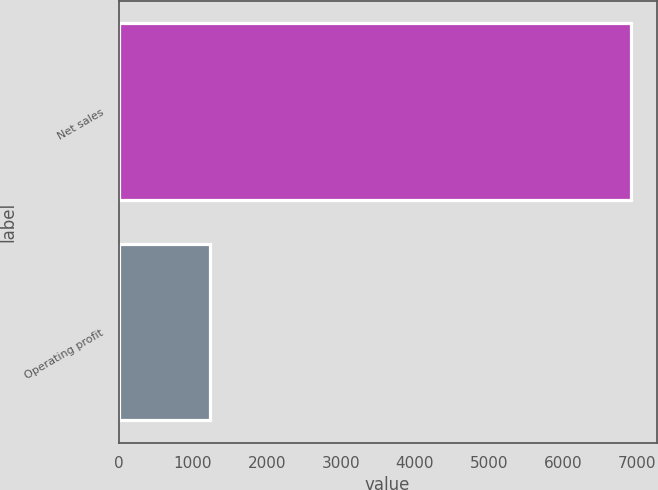Convert chart to OTSL. <chart><loc_0><loc_0><loc_500><loc_500><bar_chart><fcel>Net sales<fcel>Operating profit<nl><fcel>6917<fcel>1233<nl></chart> 